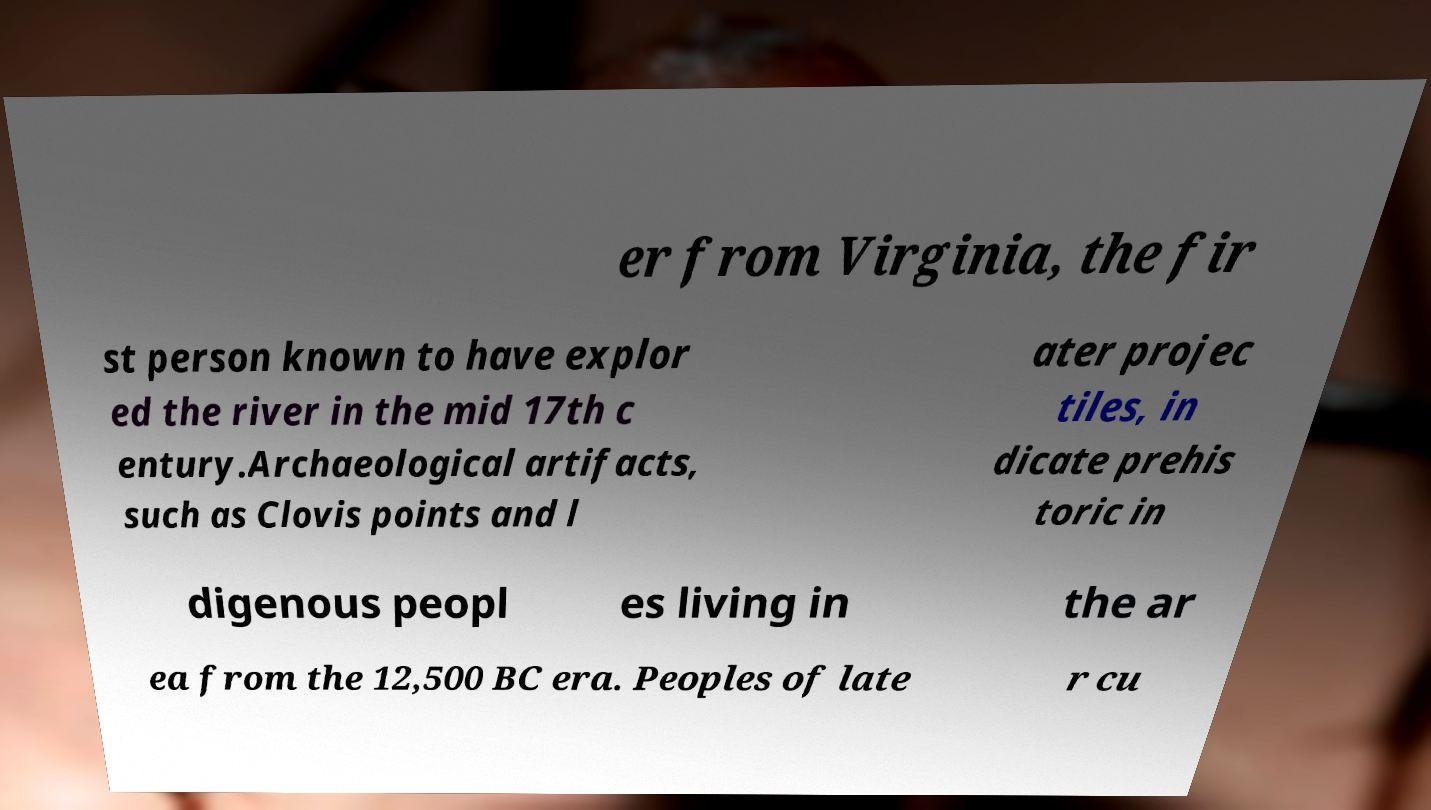I need the written content from this picture converted into text. Can you do that? er from Virginia, the fir st person known to have explor ed the river in the mid 17th c entury.Archaeological artifacts, such as Clovis points and l ater projec tiles, in dicate prehis toric in digenous peopl es living in the ar ea from the 12,500 BC era. Peoples of late r cu 